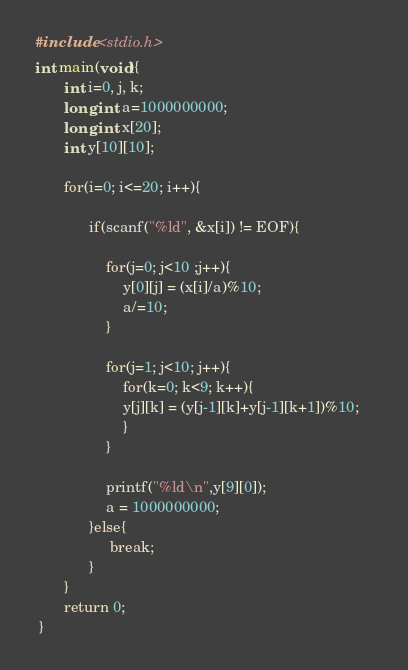Convert code to text. <code><loc_0><loc_0><loc_500><loc_500><_C_>#include <stdio.h>
int main(void){
       int i=0, j, k;
       long int a=1000000000;
       long int x[20];
       int y[10][10];
 
       for(i=0; i<=20; i++){
 
             if(scanf("%ld", &x[i]) != EOF){
 
                 for(j=0; j<10 ;j++){
                     y[0][j] = (x[i]/a)%10;
                     a/=10;
                 }
 
                 for(j=1; j<10; j++){
                     for(k=0; k<9; k++){
                     y[j][k] = (y[j-1][k]+y[j-1][k+1])%10;
                     }
                 }
                                                                                 
                 printf("%ld\n",y[9][0]);
                 a = 1000000000;
             }else{
                  break;
             }
       }
       return 0;
 }

</code> 